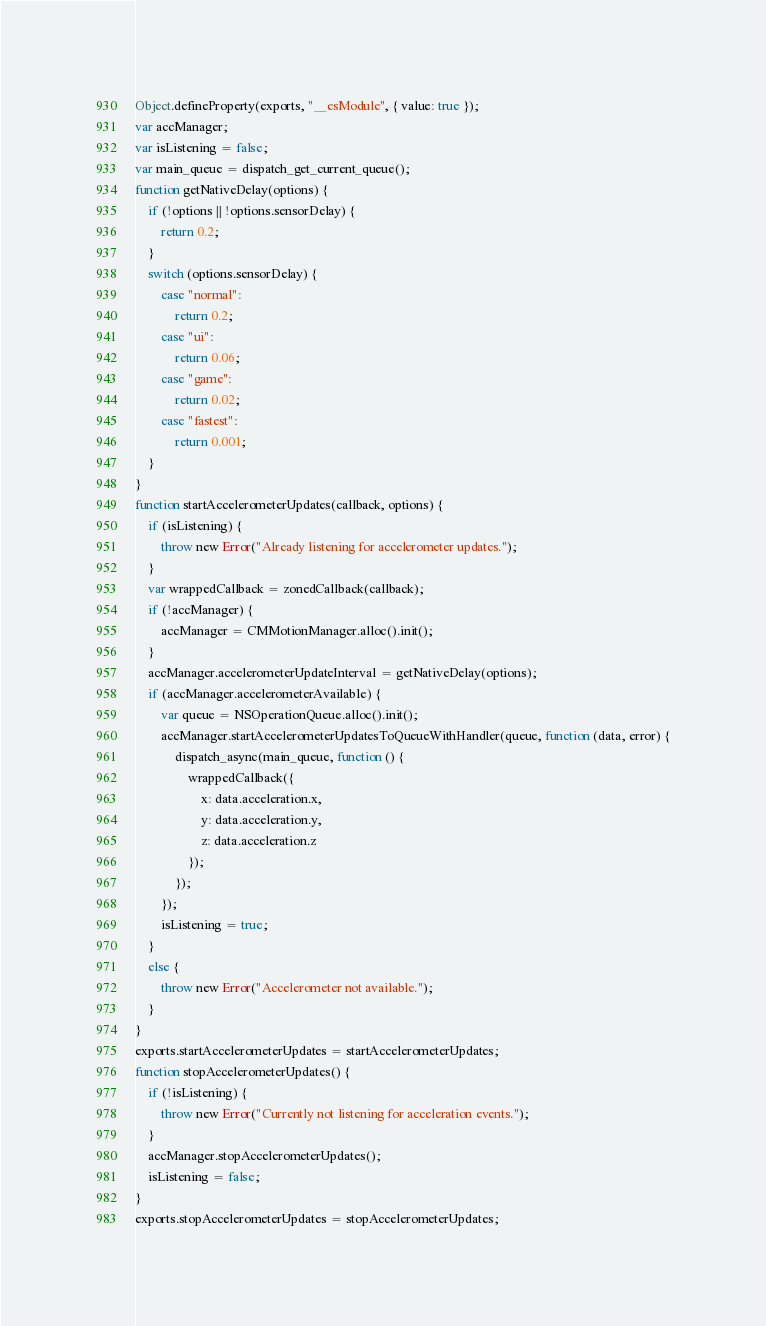Convert code to text. <code><loc_0><loc_0><loc_500><loc_500><_JavaScript_>Object.defineProperty(exports, "__esModule", { value: true });
var accManager;
var isListening = false;
var main_queue = dispatch_get_current_queue();
function getNativeDelay(options) {
    if (!options || !options.sensorDelay) {
        return 0.2;
    }
    switch (options.sensorDelay) {
        case "normal":
            return 0.2;
        case "ui":
            return 0.06;
        case "game":
            return 0.02;
        case "fastest":
            return 0.001;
    }
}
function startAccelerometerUpdates(callback, options) {
    if (isListening) {
        throw new Error("Already listening for accelerometer updates.");
    }
    var wrappedCallback = zonedCallback(callback);
    if (!accManager) {
        accManager = CMMotionManager.alloc().init();
    }
    accManager.accelerometerUpdateInterval = getNativeDelay(options);
    if (accManager.accelerometerAvailable) {
        var queue = NSOperationQueue.alloc().init();
        accManager.startAccelerometerUpdatesToQueueWithHandler(queue, function (data, error) {
            dispatch_async(main_queue, function () {
                wrappedCallback({
                    x: data.acceleration.x,
                    y: data.acceleration.y,
                    z: data.acceleration.z
                });
            });
        });
        isListening = true;
    }
    else {
        throw new Error("Accelerometer not available.");
    }
}
exports.startAccelerometerUpdates = startAccelerometerUpdates;
function stopAccelerometerUpdates() {
    if (!isListening) {
        throw new Error("Currently not listening for acceleration events.");
    }
    accManager.stopAccelerometerUpdates();
    isListening = false;
}
exports.stopAccelerometerUpdates = stopAccelerometerUpdates;
</code> 